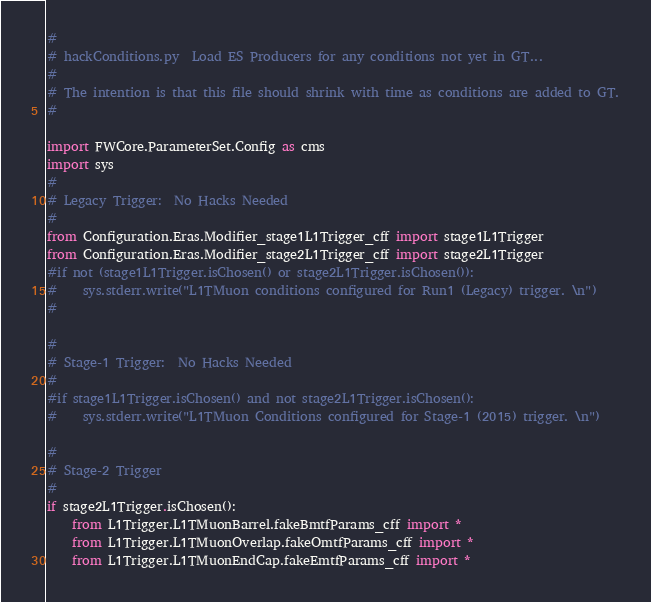Convert code to text. <code><loc_0><loc_0><loc_500><loc_500><_Python_>#
# hackConditions.py  Load ES Producers for any conditions not yet in GT...
#
# The intention is that this file should shrink with time as conditions are added to GT.
#

import FWCore.ParameterSet.Config as cms
import sys
#
# Legacy Trigger:  No Hacks Needed
#
from Configuration.Eras.Modifier_stage1L1Trigger_cff import stage1L1Trigger
from Configuration.Eras.Modifier_stage2L1Trigger_cff import stage2L1Trigger
#if not (stage1L1Trigger.isChosen() or stage2L1Trigger.isChosen()):
#    sys.stderr.write("L1TMuon conditions configured for Run1 (Legacy) trigger. \n")
# 

#
# Stage-1 Trigger:  No Hacks Needed
#
#if stage1L1Trigger.isChosen() and not stage2L1Trigger.isChosen():
#    sys.stderr.write("L1TMuon Conditions configured for Stage-1 (2015) trigger. \n")

#
# Stage-2 Trigger
#
if stage2L1Trigger.isChosen():
    from L1Trigger.L1TMuonBarrel.fakeBmtfParams_cff import *
    from L1Trigger.L1TMuonOverlap.fakeOmtfParams_cff import *
    from L1Trigger.L1TMuonEndCap.fakeEmtfParams_cff import *</code> 